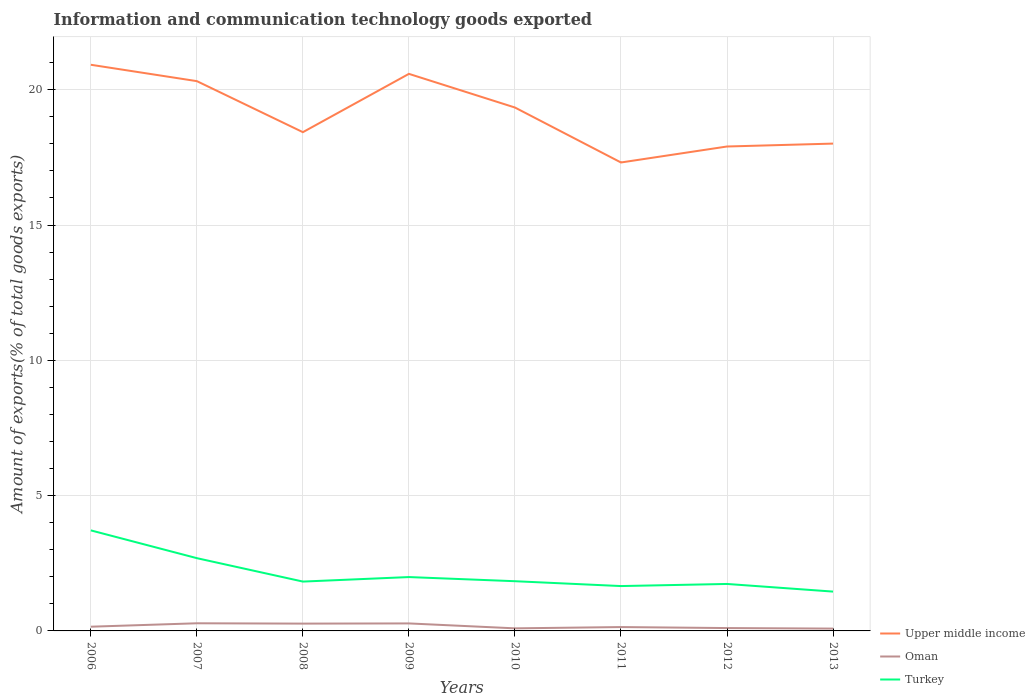Is the number of lines equal to the number of legend labels?
Offer a very short reply. Yes. Across all years, what is the maximum amount of goods exported in Oman?
Provide a succinct answer. 0.09. What is the total amount of goods exported in Upper middle income in the graph?
Ensure brevity in your answer.  1.58. What is the difference between the highest and the second highest amount of goods exported in Turkey?
Offer a very short reply. 2.26. Are the values on the major ticks of Y-axis written in scientific E-notation?
Your response must be concise. No. How are the legend labels stacked?
Offer a terse response. Vertical. What is the title of the graph?
Your answer should be very brief. Information and communication technology goods exported. What is the label or title of the Y-axis?
Make the answer very short. Amount of exports(% of total goods exports). What is the Amount of exports(% of total goods exports) of Upper middle income in 2006?
Your answer should be compact. 20.92. What is the Amount of exports(% of total goods exports) in Oman in 2006?
Ensure brevity in your answer.  0.16. What is the Amount of exports(% of total goods exports) in Turkey in 2006?
Make the answer very short. 3.72. What is the Amount of exports(% of total goods exports) in Upper middle income in 2007?
Ensure brevity in your answer.  20.32. What is the Amount of exports(% of total goods exports) of Oman in 2007?
Offer a very short reply. 0.28. What is the Amount of exports(% of total goods exports) of Turkey in 2007?
Ensure brevity in your answer.  2.69. What is the Amount of exports(% of total goods exports) in Upper middle income in 2008?
Ensure brevity in your answer.  18.43. What is the Amount of exports(% of total goods exports) of Oman in 2008?
Provide a succinct answer. 0.27. What is the Amount of exports(% of total goods exports) of Turkey in 2008?
Keep it short and to the point. 1.82. What is the Amount of exports(% of total goods exports) in Upper middle income in 2009?
Offer a terse response. 20.59. What is the Amount of exports(% of total goods exports) in Oman in 2009?
Provide a short and direct response. 0.28. What is the Amount of exports(% of total goods exports) of Turkey in 2009?
Make the answer very short. 1.99. What is the Amount of exports(% of total goods exports) of Upper middle income in 2010?
Your answer should be very brief. 19.34. What is the Amount of exports(% of total goods exports) in Oman in 2010?
Keep it short and to the point. 0.1. What is the Amount of exports(% of total goods exports) of Turkey in 2010?
Offer a terse response. 1.84. What is the Amount of exports(% of total goods exports) in Upper middle income in 2011?
Provide a succinct answer. 17.31. What is the Amount of exports(% of total goods exports) of Oman in 2011?
Offer a terse response. 0.14. What is the Amount of exports(% of total goods exports) in Turkey in 2011?
Your answer should be very brief. 1.66. What is the Amount of exports(% of total goods exports) of Upper middle income in 2012?
Make the answer very short. 17.9. What is the Amount of exports(% of total goods exports) of Oman in 2012?
Provide a short and direct response. 0.11. What is the Amount of exports(% of total goods exports) in Turkey in 2012?
Offer a terse response. 1.74. What is the Amount of exports(% of total goods exports) in Upper middle income in 2013?
Offer a terse response. 18.01. What is the Amount of exports(% of total goods exports) in Oman in 2013?
Offer a terse response. 0.09. What is the Amount of exports(% of total goods exports) of Turkey in 2013?
Offer a very short reply. 1.45. Across all years, what is the maximum Amount of exports(% of total goods exports) in Upper middle income?
Provide a short and direct response. 20.92. Across all years, what is the maximum Amount of exports(% of total goods exports) in Oman?
Offer a terse response. 0.28. Across all years, what is the maximum Amount of exports(% of total goods exports) in Turkey?
Provide a short and direct response. 3.72. Across all years, what is the minimum Amount of exports(% of total goods exports) of Upper middle income?
Your response must be concise. 17.31. Across all years, what is the minimum Amount of exports(% of total goods exports) in Oman?
Offer a very short reply. 0.09. Across all years, what is the minimum Amount of exports(% of total goods exports) in Turkey?
Your answer should be very brief. 1.45. What is the total Amount of exports(% of total goods exports) of Upper middle income in the graph?
Your response must be concise. 152.82. What is the total Amount of exports(% of total goods exports) of Oman in the graph?
Give a very brief answer. 1.42. What is the total Amount of exports(% of total goods exports) in Turkey in the graph?
Ensure brevity in your answer.  16.9. What is the difference between the Amount of exports(% of total goods exports) in Upper middle income in 2006 and that in 2007?
Offer a terse response. 0.6. What is the difference between the Amount of exports(% of total goods exports) in Oman in 2006 and that in 2007?
Provide a short and direct response. -0.13. What is the difference between the Amount of exports(% of total goods exports) of Turkey in 2006 and that in 2007?
Give a very brief answer. 1.03. What is the difference between the Amount of exports(% of total goods exports) in Upper middle income in 2006 and that in 2008?
Keep it short and to the point. 2.49. What is the difference between the Amount of exports(% of total goods exports) in Oman in 2006 and that in 2008?
Keep it short and to the point. -0.11. What is the difference between the Amount of exports(% of total goods exports) of Turkey in 2006 and that in 2008?
Provide a succinct answer. 1.89. What is the difference between the Amount of exports(% of total goods exports) of Upper middle income in 2006 and that in 2009?
Make the answer very short. 0.34. What is the difference between the Amount of exports(% of total goods exports) in Oman in 2006 and that in 2009?
Ensure brevity in your answer.  -0.12. What is the difference between the Amount of exports(% of total goods exports) of Turkey in 2006 and that in 2009?
Provide a succinct answer. 1.73. What is the difference between the Amount of exports(% of total goods exports) in Upper middle income in 2006 and that in 2010?
Offer a terse response. 1.58. What is the difference between the Amount of exports(% of total goods exports) of Oman in 2006 and that in 2010?
Your answer should be very brief. 0.06. What is the difference between the Amount of exports(% of total goods exports) of Turkey in 2006 and that in 2010?
Make the answer very short. 1.88. What is the difference between the Amount of exports(% of total goods exports) in Upper middle income in 2006 and that in 2011?
Offer a very short reply. 3.61. What is the difference between the Amount of exports(% of total goods exports) in Oman in 2006 and that in 2011?
Make the answer very short. 0.01. What is the difference between the Amount of exports(% of total goods exports) of Turkey in 2006 and that in 2011?
Your response must be concise. 2.06. What is the difference between the Amount of exports(% of total goods exports) of Upper middle income in 2006 and that in 2012?
Your response must be concise. 3.02. What is the difference between the Amount of exports(% of total goods exports) of Turkey in 2006 and that in 2012?
Give a very brief answer. 1.98. What is the difference between the Amount of exports(% of total goods exports) in Upper middle income in 2006 and that in 2013?
Your answer should be compact. 2.91. What is the difference between the Amount of exports(% of total goods exports) of Oman in 2006 and that in 2013?
Your answer should be very brief. 0.07. What is the difference between the Amount of exports(% of total goods exports) in Turkey in 2006 and that in 2013?
Make the answer very short. 2.26. What is the difference between the Amount of exports(% of total goods exports) of Upper middle income in 2007 and that in 2008?
Offer a very short reply. 1.89. What is the difference between the Amount of exports(% of total goods exports) of Oman in 2007 and that in 2008?
Provide a succinct answer. 0.01. What is the difference between the Amount of exports(% of total goods exports) in Turkey in 2007 and that in 2008?
Ensure brevity in your answer.  0.87. What is the difference between the Amount of exports(% of total goods exports) in Upper middle income in 2007 and that in 2009?
Give a very brief answer. -0.27. What is the difference between the Amount of exports(% of total goods exports) in Oman in 2007 and that in 2009?
Provide a short and direct response. 0. What is the difference between the Amount of exports(% of total goods exports) in Turkey in 2007 and that in 2009?
Provide a succinct answer. 0.7. What is the difference between the Amount of exports(% of total goods exports) in Upper middle income in 2007 and that in 2010?
Give a very brief answer. 0.97. What is the difference between the Amount of exports(% of total goods exports) of Oman in 2007 and that in 2010?
Your response must be concise. 0.19. What is the difference between the Amount of exports(% of total goods exports) in Turkey in 2007 and that in 2010?
Provide a succinct answer. 0.85. What is the difference between the Amount of exports(% of total goods exports) in Upper middle income in 2007 and that in 2011?
Offer a very short reply. 3.01. What is the difference between the Amount of exports(% of total goods exports) of Oman in 2007 and that in 2011?
Offer a terse response. 0.14. What is the difference between the Amount of exports(% of total goods exports) in Turkey in 2007 and that in 2011?
Provide a short and direct response. 1.03. What is the difference between the Amount of exports(% of total goods exports) in Upper middle income in 2007 and that in 2012?
Ensure brevity in your answer.  2.42. What is the difference between the Amount of exports(% of total goods exports) in Oman in 2007 and that in 2012?
Give a very brief answer. 0.18. What is the difference between the Amount of exports(% of total goods exports) of Turkey in 2007 and that in 2012?
Ensure brevity in your answer.  0.95. What is the difference between the Amount of exports(% of total goods exports) in Upper middle income in 2007 and that in 2013?
Your answer should be compact. 2.31. What is the difference between the Amount of exports(% of total goods exports) of Oman in 2007 and that in 2013?
Keep it short and to the point. 0.2. What is the difference between the Amount of exports(% of total goods exports) in Turkey in 2007 and that in 2013?
Offer a terse response. 1.24. What is the difference between the Amount of exports(% of total goods exports) in Upper middle income in 2008 and that in 2009?
Keep it short and to the point. -2.15. What is the difference between the Amount of exports(% of total goods exports) of Oman in 2008 and that in 2009?
Your answer should be very brief. -0.01. What is the difference between the Amount of exports(% of total goods exports) of Turkey in 2008 and that in 2009?
Keep it short and to the point. -0.17. What is the difference between the Amount of exports(% of total goods exports) of Upper middle income in 2008 and that in 2010?
Give a very brief answer. -0.91. What is the difference between the Amount of exports(% of total goods exports) in Oman in 2008 and that in 2010?
Your answer should be compact. 0.17. What is the difference between the Amount of exports(% of total goods exports) of Turkey in 2008 and that in 2010?
Your answer should be compact. -0.01. What is the difference between the Amount of exports(% of total goods exports) in Upper middle income in 2008 and that in 2011?
Give a very brief answer. 1.12. What is the difference between the Amount of exports(% of total goods exports) of Oman in 2008 and that in 2011?
Ensure brevity in your answer.  0.13. What is the difference between the Amount of exports(% of total goods exports) of Turkey in 2008 and that in 2011?
Your response must be concise. 0.17. What is the difference between the Amount of exports(% of total goods exports) of Upper middle income in 2008 and that in 2012?
Ensure brevity in your answer.  0.53. What is the difference between the Amount of exports(% of total goods exports) in Oman in 2008 and that in 2012?
Your answer should be compact. 0.16. What is the difference between the Amount of exports(% of total goods exports) in Turkey in 2008 and that in 2012?
Provide a succinct answer. 0.09. What is the difference between the Amount of exports(% of total goods exports) in Upper middle income in 2008 and that in 2013?
Keep it short and to the point. 0.42. What is the difference between the Amount of exports(% of total goods exports) in Oman in 2008 and that in 2013?
Offer a very short reply. 0.18. What is the difference between the Amount of exports(% of total goods exports) of Turkey in 2008 and that in 2013?
Provide a succinct answer. 0.37. What is the difference between the Amount of exports(% of total goods exports) of Upper middle income in 2009 and that in 2010?
Ensure brevity in your answer.  1.24. What is the difference between the Amount of exports(% of total goods exports) in Oman in 2009 and that in 2010?
Your answer should be compact. 0.18. What is the difference between the Amount of exports(% of total goods exports) in Turkey in 2009 and that in 2010?
Offer a terse response. 0.15. What is the difference between the Amount of exports(% of total goods exports) of Upper middle income in 2009 and that in 2011?
Make the answer very short. 3.27. What is the difference between the Amount of exports(% of total goods exports) in Oman in 2009 and that in 2011?
Provide a succinct answer. 0.13. What is the difference between the Amount of exports(% of total goods exports) of Turkey in 2009 and that in 2011?
Provide a short and direct response. 0.33. What is the difference between the Amount of exports(% of total goods exports) in Upper middle income in 2009 and that in 2012?
Ensure brevity in your answer.  2.68. What is the difference between the Amount of exports(% of total goods exports) in Oman in 2009 and that in 2012?
Provide a succinct answer. 0.17. What is the difference between the Amount of exports(% of total goods exports) in Turkey in 2009 and that in 2012?
Offer a very short reply. 0.25. What is the difference between the Amount of exports(% of total goods exports) in Upper middle income in 2009 and that in 2013?
Make the answer very short. 2.58. What is the difference between the Amount of exports(% of total goods exports) of Oman in 2009 and that in 2013?
Keep it short and to the point. 0.19. What is the difference between the Amount of exports(% of total goods exports) in Turkey in 2009 and that in 2013?
Provide a short and direct response. 0.54. What is the difference between the Amount of exports(% of total goods exports) of Upper middle income in 2010 and that in 2011?
Your answer should be very brief. 2.03. What is the difference between the Amount of exports(% of total goods exports) in Oman in 2010 and that in 2011?
Keep it short and to the point. -0.05. What is the difference between the Amount of exports(% of total goods exports) in Turkey in 2010 and that in 2011?
Your answer should be very brief. 0.18. What is the difference between the Amount of exports(% of total goods exports) in Upper middle income in 2010 and that in 2012?
Your response must be concise. 1.44. What is the difference between the Amount of exports(% of total goods exports) in Oman in 2010 and that in 2012?
Your response must be concise. -0.01. What is the difference between the Amount of exports(% of total goods exports) in Turkey in 2010 and that in 2012?
Ensure brevity in your answer.  0.1. What is the difference between the Amount of exports(% of total goods exports) of Upper middle income in 2010 and that in 2013?
Make the answer very short. 1.33. What is the difference between the Amount of exports(% of total goods exports) of Oman in 2010 and that in 2013?
Your response must be concise. 0.01. What is the difference between the Amount of exports(% of total goods exports) in Turkey in 2010 and that in 2013?
Keep it short and to the point. 0.38. What is the difference between the Amount of exports(% of total goods exports) in Upper middle income in 2011 and that in 2012?
Your answer should be very brief. -0.59. What is the difference between the Amount of exports(% of total goods exports) in Oman in 2011 and that in 2012?
Your response must be concise. 0.04. What is the difference between the Amount of exports(% of total goods exports) in Turkey in 2011 and that in 2012?
Your answer should be compact. -0.08. What is the difference between the Amount of exports(% of total goods exports) in Upper middle income in 2011 and that in 2013?
Make the answer very short. -0.7. What is the difference between the Amount of exports(% of total goods exports) of Oman in 2011 and that in 2013?
Offer a very short reply. 0.06. What is the difference between the Amount of exports(% of total goods exports) in Turkey in 2011 and that in 2013?
Provide a succinct answer. 0.2. What is the difference between the Amount of exports(% of total goods exports) of Upper middle income in 2012 and that in 2013?
Your response must be concise. -0.11. What is the difference between the Amount of exports(% of total goods exports) in Oman in 2012 and that in 2013?
Offer a terse response. 0.02. What is the difference between the Amount of exports(% of total goods exports) in Turkey in 2012 and that in 2013?
Your answer should be very brief. 0.28. What is the difference between the Amount of exports(% of total goods exports) of Upper middle income in 2006 and the Amount of exports(% of total goods exports) of Oman in 2007?
Provide a succinct answer. 20.64. What is the difference between the Amount of exports(% of total goods exports) in Upper middle income in 2006 and the Amount of exports(% of total goods exports) in Turkey in 2007?
Offer a terse response. 18.23. What is the difference between the Amount of exports(% of total goods exports) of Oman in 2006 and the Amount of exports(% of total goods exports) of Turkey in 2007?
Offer a very short reply. -2.53. What is the difference between the Amount of exports(% of total goods exports) in Upper middle income in 2006 and the Amount of exports(% of total goods exports) in Oman in 2008?
Ensure brevity in your answer.  20.65. What is the difference between the Amount of exports(% of total goods exports) of Upper middle income in 2006 and the Amount of exports(% of total goods exports) of Turkey in 2008?
Keep it short and to the point. 19.1. What is the difference between the Amount of exports(% of total goods exports) in Oman in 2006 and the Amount of exports(% of total goods exports) in Turkey in 2008?
Offer a terse response. -1.67. What is the difference between the Amount of exports(% of total goods exports) in Upper middle income in 2006 and the Amount of exports(% of total goods exports) in Oman in 2009?
Provide a short and direct response. 20.64. What is the difference between the Amount of exports(% of total goods exports) in Upper middle income in 2006 and the Amount of exports(% of total goods exports) in Turkey in 2009?
Make the answer very short. 18.93. What is the difference between the Amount of exports(% of total goods exports) of Oman in 2006 and the Amount of exports(% of total goods exports) of Turkey in 2009?
Ensure brevity in your answer.  -1.83. What is the difference between the Amount of exports(% of total goods exports) of Upper middle income in 2006 and the Amount of exports(% of total goods exports) of Oman in 2010?
Your answer should be very brief. 20.83. What is the difference between the Amount of exports(% of total goods exports) of Upper middle income in 2006 and the Amount of exports(% of total goods exports) of Turkey in 2010?
Keep it short and to the point. 19.08. What is the difference between the Amount of exports(% of total goods exports) in Oman in 2006 and the Amount of exports(% of total goods exports) in Turkey in 2010?
Your answer should be very brief. -1.68. What is the difference between the Amount of exports(% of total goods exports) of Upper middle income in 2006 and the Amount of exports(% of total goods exports) of Oman in 2011?
Give a very brief answer. 20.78. What is the difference between the Amount of exports(% of total goods exports) of Upper middle income in 2006 and the Amount of exports(% of total goods exports) of Turkey in 2011?
Provide a short and direct response. 19.26. What is the difference between the Amount of exports(% of total goods exports) in Oman in 2006 and the Amount of exports(% of total goods exports) in Turkey in 2011?
Offer a terse response. -1.5. What is the difference between the Amount of exports(% of total goods exports) of Upper middle income in 2006 and the Amount of exports(% of total goods exports) of Oman in 2012?
Provide a succinct answer. 20.82. What is the difference between the Amount of exports(% of total goods exports) of Upper middle income in 2006 and the Amount of exports(% of total goods exports) of Turkey in 2012?
Offer a very short reply. 19.19. What is the difference between the Amount of exports(% of total goods exports) of Oman in 2006 and the Amount of exports(% of total goods exports) of Turkey in 2012?
Provide a short and direct response. -1.58. What is the difference between the Amount of exports(% of total goods exports) in Upper middle income in 2006 and the Amount of exports(% of total goods exports) in Oman in 2013?
Keep it short and to the point. 20.84. What is the difference between the Amount of exports(% of total goods exports) of Upper middle income in 2006 and the Amount of exports(% of total goods exports) of Turkey in 2013?
Provide a succinct answer. 19.47. What is the difference between the Amount of exports(% of total goods exports) in Oman in 2006 and the Amount of exports(% of total goods exports) in Turkey in 2013?
Give a very brief answer. -1.3. What is the difference between the Amount of exports(% of total goods exports) of Upper middle income in 2007 and the Amount of exports(% of total goods exports) of Oman in 2008?
Ensure brevity in your answer.  20.05. What is the difference between the Amount of exports(% of total goods exports) in Upper middle income in 2007 and the Amount of exports(% of total goods exports) in Turkey in 2008?
Give a very brief answer. 18.49. What is the difference between the Amount of exports(% of total goods exports) in Oman in 2007 and the Amount of exports(% of total goods exports) in Turkey in 2008?
Your answer should be compact. -1.54. What is the difference between the Amount of exports(% of total goods exports) of Upper middle income in 2007 and the Amount of exports(% of total goods exports) of Oman in 2009?
Your response must be concise. 20.04. What is the difference between the Amount of exports(% of total goods exports) of Upper middle income in 2007 and the Amount of exports(% of total goods exports) of Turkey in 2009?
Provide a succinct answer. 18.33. What is the difference between the Amount of exports(% of total goods exports) of Oman in 2007 and the Amount of exports(% of total goods exports) of Turkey in 2009?
Ensure brevity in your answer.  -1.71. What is the difference between the Amount of exports(% of total goods exports) of Upper middle income in 2007 and the Amount of exports(% of total goods exports) of Oman in 2010?
Keep it short and to the point. 20.22. What is the difference between the Amount of exports(% of total goods exports) in Upper middle income in 2007 and the Amount of exports(% of total goods exports) in Turkey in 2010?
Keep it short and to the point. 18.48. What is the difference between the Amount of exports(% of total goods exports) of Oman in 2007 and the Amount of exports(% of total goods exports) of Turkey in 2010?
Your response must be concise. -1.55. What is the difference between the Amount of exports(% of total goods exports) of Upper middle income in 2007 and the Amount of exports(% of total goods exports) of Oman in 2011?
Your answer should be very brief. 20.17. What is the difference between the Amount of exports(% of total goods exports) in Upper middle income in 2007 and the Amount of exports(% of total goods exports) in Turkey in 2011?
Your response must be concise. 18.66. What is the difference between the Amount of exports(% of total goods exports) in Oman in 2007 and the Amount of exports(% of total goods exports) in Turkey in 2011?
Make the answer very short. -1.38. What is the difference between the Amount of exports(% of total goods exports) of Upper middle income in 2007 and the Amount of exports(% of total goods exports) of Oman in 2012?
Your answer should be very brief. 20.21. What is the difference between the Amount of exports(% of total goods exports) in Upper middle income in 2007 and the Amount of exports(% of total goods exports) in Turkey in 2012?
Provide a succinct answer. 18.58. What is the difference between the Amount of exports(% of total goods exports) of Oman in 2007 and the Amount of exports(% of total goods exports) of Turkey in 2012?
Provide a short and direct response. -1.45. What is the difference between the Amount of exports(% of total goods exports) of Upper middle income in 2007 and the Amount of exports(% of total goods exports) of Oman in 2013?
Your answer should be very brief. 20.23. What is the difference between the Amount of exports(% of total goods exports) in Upper middle income in 2007 and the Amount of exports(% of total goods exports) in Turkey in 2013?
Provide a short and direct response. 18.86. What is the difference between the Amount of exports(% of total goods exports) in Oman in 2007 and the Amount of exports(% of total goods exports) in Turkey in 2013?
Give a very brief answer. -1.17. What is the difference between the Amount of exports(% of total goods exports) of Upper middle income in 2008 and the Amount of exports(% of total goods exports) of Oman in 2009?
Your answer should be compact. 18.15. What is the difference between the Amount of exports(% of total goods exports) in Upper middle income in 2008 and the Amount of exports(% of total goods exports) in Turkey in 2009?
Your answer should be compact. 16.44. What is the difference between the Amount of exports(% of total goods exports) of Oman in 2008 and the Amount of exports(% of total goods exports) of Turkey in 2009?
Offer a very short reply. -1.72. What is the difference between the Amount of exports(% of total goods exports) of Upper middle income in 2008 and the Amount of exports(% of total goods exports) of Oman in 2010?
Your response must be concise. 18.34. What is the difference between the Amount of exports(% of total goods exports) of Upper middle income in 2008 and the Amount of exports(% of total goods exports) of Turkey in 2010?
Offer a very short reply. 16.59. What is the difference between the Amount of exports(% of total goods exports) in Oman in 2008 and the Amount of exports(% of total goods exports) in Turkey in 2010?
Your answer should be very brief. -1.57. What is the difference between the Amount of exports(% of total goods exports) of Upper middle income in 2008 and the Amount of exports(% of total goods exports) of Oman in 2011?
Your answer should be very brief. 18.29. What is the difference between the Amount of exports(% of total goods exports) in Upper middle income in 2008 and the Amount of exports(% of total goods exports) in Turkey in 2011?
Offer a terse response. 16.77. What is the difference between the Amount of exports(% of total goods exports) of Oman in 2008 and the Amount of exports(% of total goods exports) of Turkey in 2011?
Your answer should be compact. -1.39. What is the difference between the Amount of exports(% of total goods exports) in Upper middle income in 2008 and the Amount of exports(% of total goods exports) in Oman in 2012?
Offer a very short reply. 18.33. What is the difference between the Amount of exports(% of total goods exports) of Upper middle income in 2008 and the Amount of exports(% of total goods exports) of Turkey in 2012?
Ensure brevity in your answer.  16.7. What is the difference between the Amount of exports(% of total goods exports) of Oman in 2008 and the Amount of exports(% of total goods exports) of Turkey in 2012?
Keep it short and to the point. -1.47. What is the difference between the Amount of exports(% of total goods exports) of Upper middle income in 2008 and the Amount of exports(% of total goods exports) of Oman in 2013?
Your response must be concise. 18.35. What is the difference between the Amount of exports(% of total goods exports) of Upper middle income in 2008 and the Amount of exports(% of total goods exports) of Turkey in 2013?
Provide a succinct answer. 16.98. What is the difference between the Amount of exports(% of total goods exports) in Oman in 2008 and the Amount of exports(% of total goods exports) in Turkey in 2013?
Keep it short and to the point. -1.18. What is the difference between the Amount of exports(% of total goods exports) of Upper middle income in 2009 and the Amount of exports(% of total goods exports) of Oman in 2010?
Make the answer very short. 20.49. What is the difference between the Amount of exports(% of total goods exports) in Upper middle income in 2009 and the Amount of exports(% of total goods exports) in Turkey in 2010?
Provide a short and direct response. 18.75. What is the difference between the Amount of exports(% of total goods exports) of Oman in 2009 and the Amount of exports(% of total goods exports) of Turkey in 2010?
Ensure brevity in your answer.  -1.56. What is the difference between the Amount of exports(% of total goods exports) of Upper middle income in 2009 and the Amount of exports(% of total goods exports) of Oman in 2011?
Ensure brevity in your answer.  20.44. What is the difference between the Amount of exports(% of total goods exports) in Upper middle income in 2009 and the Amount of exports(% of total goods exports) in Turkey in 2011?
Offer a very short reply. 18.93. What is the difference between the Amount of exports(% of total goods exports) in Oman in 2009 and the Amount of exports(% of total goods exports) in Turkey in 2011?
Offer a very short reply. -1.38. What is the difference between the Amount of exports(% of total goods exports) in Upper middle income in 2009 and the Amount of exports(% of total goods exports) in Oman in 2012?
Ensure brevity in your answer.  20.48. What is the difference between the Amount of exports(% of total goods exports) in Upper middle income in 2009 and the Amount of exports(% of total goods exports) in Turkey in 2012?
Your answer should be compact. 18.85. What is the difference between the Amount of exports(% of total goods exports) of Oman in 2009 and the Amount of exports(% of total goods exports) of Turkey in 2012?
Your answer should be compact. -1.46. What is the difference between the Amount of exports(% of total goods exports) in Upper middle income in 2009 and the Amount of exports(% of total goods exports) in Oman in 2013?
Offer a very short reply. 20.5. What is the difference between the Amount of exports(% of total goods exports) of Upper middle income in 2009 and the Amount of exports(% of total goods exports) of Turkey in 2013?
Provide a short and direct response. 19.13. What is the difference between the Amount of exports(% of total goods exports) of Oman in 2009 and the Amount of exports(% of total goods exports) of Turkey in 2013?
Make the answer very short. -1.18. What is the difference between the Amount of exports(% of total goods exports) of Upper middle income in 2010 and the Amount of exports(% of total goods exports) of Oman in 2011?
Keep it short and to the point. 19.2. What is the difference between the Amount of exports(% of total goods exports) of Upper middle income in 2010 and the Amount of exports(% of total goods exports) of Turkey in 2011?
Provide a succinct answer. 17.68. What is the difference between the Amount of exports(% of total goods exports) in Oman in 2010 and the Amount of exports(% of total goods exports) in Turkey in 2011?
Your answer should be very brief. -1.56. What is the difference between the Amount of exports(% of total goods exports) of Upper middle income in 2010 and the Amount of exports(% of total goods exports) of Oman in 2012?
Offer a terse response. 19.24. What is the difference between the Amount of exports(% of total goods exports) in Upper middle income in 2010 and the Amount of exports(% of total goods exports) in Turkey in 2012?
Keep it short and to the point. 17.61. What is the difference between the Amount of exports(% of total goods exports) in Oman in 2010 and the Amount of exports(% of total goods exports) in Turkey in 2012?
Give a very brief answer. -1.64. What is the difference between the Amount of exports(% of total goods exports) in Upper middle income in 2010 and the Amount of exports(% of total goods exports) in Oman in 2013?
Your answer should be compact. 19.26. What is the difference between the Amount of exports(% of total goods exports) of Upper middle income in 2010 and the Amount of exports(% of total goods exports) of Turkey in 2013?
Keep it short and to the point. 17.89. What is the difference between the Amount of exports(% of total goods exports) of Oman in 2010 and the Amount of exports(% of total goods exports) of Turkey in 2013?
Your answer should be compact. -1.36. What is the difference between the Amount of exports(% of total goods exports) in Upper middle income in 2011 and the Amount of exports(% of total goods exports) in Oman in 2012?
Provide a short and direct response. 17.21. What is the difference between the Amount of exports(% of total goods exports) of Upper middle income in 2011 and the Amount of exports(% of total goods exports) of Turkey in 2012?
Your response must be concise. 15.58. What is the difference between the Amount of exports(% of total goods exports) in Oman in 2011 and the Amount of exports(% of total goods exports) in Turkey in 2012?
Offer a terse response. -1.59. What is the difference between the Amount of exports(% of total goods exports) in Upper middle income in 2011 and the Amount of exports(% of total goods exports) in Oman in 2013?
Keep it short and to the point. 17.23. What is the difference between the Amount of exports(% of total goods exports) in Upper middle income in 2011 and the Amount of exports(% of total goods exports) in Turkey in 2013?
Keep it short and to the point. 15.86. What is the difference between the Amount of exports(% of total goods exports) in Oman in 2011 and the Amount of exports(% of total goods exports) in Turkey in 2013?
Provide a short and direct response. -1.31. What is the difference between the Amount of exports(% of total goods exports) of Upper middle income in 2012 and the Amount of exports(% of total goods exports) of Oman in 2013?
Make the answer very short. 17.82. What is the difference between the Amount of exports(% of total goods exports) in Upper middle income in 2012 and the Amount of exports(% of total goods exports) in Turkey in 2013?
Offer a very short reply. 16.45. What is the difference between the Amount of exports(% of total goods exports) of Oman in 2012 and the Amount of exports(% of total goods exports) of Turkey in 2013?
Provide a short and direct response. -1.35. What is the average Amount of exports(% of total goods exports) of Upper middle income per year?
Provide a short and direct response. 19.1. What is the average Amount of exports(% of total goods exports) in Oman per year?
Your answer should be compact. 0.18. What is the average Amount of exports(% of total goods exports) of Turkey per year?
Ensure brevity in your answer.  2.11. In the year 2006, what is the difference between the Amount of exports(% of total goods exports) in Upper middle income and Amount of exports(% of total goods exports) in Oman?
Make the answer very short. 20.77. In the year 2006, what is the difference between the Amount of exports(% of total goods exports) in Upper middle income and Amount of exports(% of total goods exports) in Turkey?
Keep it short and to the point. 17.21. In the year 2006, what is the difference between the Amount of exports(% of total goods exports) in Oman and Amount of exports(% of total goods exports) in Turkey?
Give a very brief answer. -3.56. In the year 2007, what is the difference between the Amount of exports(% of total goods exports) in Upper middle income and Amount of exports(% of total goods exports) in Oman?
Your answer should be compact. 20.03. In the year 2007, what is the difference between the Amount of exports(% of total goods exports) of Upper middle income and Amount of exports(% of total goods exports) of Turkey?
Provide a succinct answer. 17.63. In the year 2007, what is the difference between the Amount of exports(% of total goods exports) in Oman and Amount of exports(% of total goods exports) in Turkey?
Provide a succinct answer. -2.41. In the year 2008, what is the difference between the Amount of exports(% of total goods exports) in Upper middle income and Amount of exports(% of total goods exports) in Oman?
Give a very brief answer. 18.16. In the year 2008, what is the difference between the Amount of exports(% of total goods exports) in Upper middle income and Amount of exports(% of total goods exports) in Turkey?
Offer a terse response. 16.61. In the year 2008, what is the difference between the Amount of exports(% of total goods exports) in Oman and Amount of exports(% of total goods exports) in Turkey?
Your answer should be compact. -1.55. In the year 2009, what is the difference between the Amount of exports(% of total goods exports) in Upper middle income and Amount of exports(% of total goods exports) in Oman?
Your response must be concise. 20.31. In the year 2009, what is the difference between the Amount of exports(% of total goods exports) of Upper middle income and Amount of exports(% of total goods exports) of Turkey?
Offer a very short reply. 18.6. In the year 2009, what is the difference between the Amount of exports(% of total goods exports) in Oman and Amount of exports(% of total goods exports) in Turkey?
Provide a succinct answer. -1.71. In the year 2010, what is the difference between the Amount of exports(% of total goods exports) of Upper middle income and Amount of exports(% of total goods exports) of Oman?
Your answer should be very brief. 19.25. In the year 2010, what is the difference between the Amount of exports(% of total goods exports) of Upper middle income and Amount of exports(% of total goods exports) of Turkey?
Offer a very short reply. 17.5. In the year 2010, what is the difference between the Amount of exports(% of total goods exports) in Oman and Amount of exports(% of total goods exports) in Turkey?
Offer a terse response. -1.74. In the year 2011, what is the difference between the Amount of exports(% of total goods exports) of Upper middle income and Amount of exports(% of total goods exports) of Oman?
Ensure brevity in your answer.  17.17. In the year 2011, what is the difference between the Amount of exports(% of total goods exports) of Upper middle income and Amount of exports(% of total goods exports) of Turkey?
Provide a succinct answer. 15.65. In the year 2011, what is the difference between the Amount of exports(% of total goods exports) in Oman and Amount of exports(% of total goods exports) in Turkey?
Offer a very short reply. -1.51. In the year 2012, what is the difference between the Amount of exports(% of total goods exports) in Upper middle income and Amount of exports(% of total goods exports) in Oman?
Your answer should be compact. 17.8. In the year 2012, what is the difference between the Amount of exports(% of total goods exports) of Upper middle income and Amount of exports(% of total goods exports) of Turkey?
Your response must be concise. 16.17. In the year 2012, what is the difference between the Amount of exports(% of total goods exports) of Oman and Amount of exports(% of total goods exports) of Turkey?
Offer a very short reply. -1.63. In the year 2013, what is the difference between the Amount of exports(% of total goods exports) of Upper middle income and Amount of exports(% of total goods exports) of Oman?
Provide a short and direct response. 17.92. In the year 2013, what is the difference between the Amount of exports(% of total goods exports) in Upper middle income and Amount of exports(% of total goods exports) in Turkey?
Your response must be concise. 16.56. In the year 2013, what is the difference between the Amount of exports(% of total goods exports) in Oman and Amount of exports(% of total goods exports) in Turkey?
Give a very brief answer. -1.37. What is the ratio of the Amount of exports(% of total goods exports) of Upper middle income in 2006 to that in 2007?
Offer a very short reply. 1.03. What is the ratio of the Amount of exports(% of total goods exports) in Oman in 2006 to that in 2007?
Keep it short and to the point. 0.55. What is the ratio of the Amount of exports(% of total goods exports) in Turkey in 2006 to that in 2007?
Provide a succinct answer. 1.38. What is the ratio of the Amount of exports(% of total goods exports) in Upper middle income in 2006 to that in 2008?
Your response must be concise. 1.14. What is the ratio of the Amount of exports(% of total goods exports) of Oman in 2006 to that in 2008?
Offer a terse response. 0.58. What is the ratio of the Amount of exports(% of total goods exports) in Turkey in 2006 to that in 2008?
Provide a succinct answer. 2.04. What is the ratio of the Amount of exports(% of total goods exports) in Upper middle income in 2006 to that in 2009?
Your answer should be very brief. 1.02. What is the ratio of the Amount of exports(% of total goods exports) of Oman in 2006 to that in 2009?
Keep it short and to the point. 0.56. What is the ratio of the Amount of exports(% of total goods exports) of Turkey in 2006 to that in 2009?
Keep it short and to the point. 1.87. What is the ratio of the Amount of exports(% of total goods exports) in Upper middle income in 2006 to that in 2010?
Offer a terse response. 1.08. What is the ratio of the Amount of exports(% of total goods exports) in Oman in 2006 to that in 2010?
Provide a succinct answer. 1.63. What is the ratio of the Amount of exports(% of total goods exports) in Turkey in 2006 to that in 2010?
Provide a short and direct response. 2.02. What is the ratio of the Amount of exports(% of total goods exports) of Upper middle income in 2006 to that in 2011?
Provide a short and direct response. 1.21. What is the ratio of the Amount of exports(% of total goods exports) of Oman in 2006 to that in 2011?
Your answer should be compact. 1.09. What is the ratio of the Amount of exports(% of total goods exports) of Turkey in 2006 to that in 2011?
Make the answer very short. 2.24. What is the ratio of the Amount of exports(% of total goods exports) in Upper middle income in 2006 to that in 2012?
Offer a very short reply. 1.17. What is the ratio of the Amount of exports(% of total goods exports) of Oman in 2006 to that in 2012?
Your answer should be compact. 1.47. What is the ratio of the Amount of exports(% of total goods exports) in Turkey in 2006 to that in 2012?
Give a very brief answer. 2.14. What is the ratio of the Amount of exports(% of total goods exports) in Upper middle income in 2006 to that in 2013?
Give a very brief answer. 1.16. What is the ratio of the Amount of exports(% of total goods exports) in Oman in 2006 to that in 2013?
Make the answer very short. 1.82. What is the ratio of the Amount of exports(% of total goods exports) in Turkey in 2006 to that in 2013?
Provide a short and direct response. 2.56. What is the ratio of the Amount of exports(% of total goods exports) of Upper middle income in 2007 to that in 2008?
Your answer should be very brief. 1.1. What is the ratio of the Amount of exports(% of total goods exports) of Oman in 2007 to that in 2008?
Give a very brief answer. 1.04. What is the ratio of the Amount of exports(% of total goods exports) in Turkey in 2007 to that in 2008?
Your answer should be very brief. 1.47. What is the ratio of the Amount of exports(% of total goods exports) of Upper middle income in 2007 to that in 2009?
Your response must be concise. 0.99. What is the ratio of the Amount of exports(% of total goods exports) of Oman in 2007 to that in 2009?
Your answer should be compact. 1.02. What is the ratio of the Amount of exports(% of total goods exports) of Turkey in 2007 to that in 2009?
Ensure brevity in your answer.  1.35. What is the ratio of the Amount of exports(% of total goods exports) of Upper middle income in 2007 to that in 2010?
Provide a succinct answer. 1.05. What is the ratio of the Amount of exports(% of total goods exports) of Oman in 2007 to that in 2010?
Keep it short and to the point. 2.96. What is the ratio of the Amount of exports(% of total goods exports) in Turkey in 2007 to that in 2010?
Provide a succinct answer. 1.46. What is the ratio of the Amount of exports(% of total goods exports) of Upper middle income in 2007 to that in 2011?
Your response must be concise. 1.17. What is the ratio of the Amount of exports(% of total goods exports) in Oman in 2007 to that in 2011?
Keep it short and to the point. 1.98. What is the ratio of the Amount of exports(% of total goods exports) in Turkey in 2007 to that in 2011?
Your answer should be compact. 1.62. What is the ratio of the Amount of exports(% of total goods exports) in Upper middle income in 2007 to that in 2012?
Your response must be concise. 1.13. What is the ratio of the Amount of exports(% of total goods exports) in Oman in 2007 to that in 2012?
Your response must be concise. 2.67. What is the ratio of the Amount of exports(% of total goods exports) in Turkey in 2007 to that in 2012?
Your answer should be compact. 1.55. What is the ratio of the Amount of exports(% of total goods exports) in Upper middle income in 2007 to that in 2013?
Make the answer very short. 1.13. What is the ratio of the Amount of exports(% of total goods exports) in Oman in 2007 to that in 2013?
Your answer should be compact. 3.29. What is the ratio of the Amount of exports(% of total goods exports) of Turkey in 2007 to that in 2013?
Your answer should be compact. 1.85. What is the ratio of the Amount of exports(% of total goods exports) in Upper middle income in 2008 to that in 2009?
Provide a succinct answer. 0.9. What is the ratio of the Amount of exports(% of total goods exports) in Oman in 2008 to that in 2009?
Ensure brevity in your answer.  0.97. What is the ratio of the Amount of exports(% of total goods exports) in Turkey in 2008 to that in 2009?
Provide a succinct answer. 0.92. What is the ratio of the Amount of exports(% of total goods exports) in Upper middle income in 2008 to that in 2010?
Give a very brief answer. 0.95. What is the ratio of the Amount of exports(% of total goods exports) of Oman in 2008 to that in 2010?
Offer a terse response. 2.83. What is the ratio of the Amount of exports(% of total goods exports) in Upper middle income in 2008 to that in 2011?
Ensure brevity in your answer.  1.06. What is the ratio of the Amount of exports(% of total goods exports) in Oman in 2008 to that in 2011?
Ensure brevity in your answer.  1.89. What is the ratio of the Amount of exports(% of total goods exports) in Turkey in 2008 to that in 2011?
Keep it short and to the point. 1.1. What is the ratio of the Amount of exports(% of total goods exports) in Upper middle income in 2008 to that in 2012?
Provide a succinct answer. 1.03. What is the ratio of the Amount of exports(% of total goods exports) of Oman in 2008 to that in 2012?
Give a very brief answer. 2.55. What is the ratio of the Amount of exports(% of total goods exports) in Turkey in 2008 to that in 2012?
Your answer should be very brief. 1.05. What is the ratio of the Amount of exports(% of total goods exports) in Upper middle income in 2008 to that in 2013?
Your answer should be compact. 1.02. What is the ratio of the Amount of exports(% of total goods exports) in Oman in 2008 to that in 2013?
Keep it short and to the point. 3.15. What is the ratio of the Amount of exports(% of total goods exports) in Turkey in 2008 to that in 2013?
Offer a very short reply. 1.25. What is the ratio of the Amount of exports(% of total goods exports) in Upper middle income in 2009 to that in 2010?
Ensure brevity in your answer.  1.06. What is the ratio of the Amount of exports(% of total goods exports) of Oman in 2009 to that in 2010?
Ensure brevity in your answer.  2.91. What is the ratio of the Amount of exports(% of total goods exports) of Turkey in 2009 to that in 2010?
Your answer should be very brief. 1.08. What is the ratio of the Amount of exports(% of total goods exports) of Upper middle income in 2009 to that in 2011?
Your answer should be compact. 1.19. What is the ratio of the Amount of exports(% of total goods exports) of Oman in 2009 to that in 2011?
Your answer should be very brief. 1.94. What is the ratio of the Amount of exports(% of total goods exports) in Turkey in 2009 to that in 2011?
Keep it short and to the point. 1.2. What is the ratio of the Amount of exports(% of total goods exports) of Upper middle income in 2009 to that in 2012?
Ensure brevity in your answer.  1.15. What is the ratio of the Amount of exports(% of total goods exports) in Oman in 2009 to that in 2012?
Your response must be concise. 2.62. What is the ratio of the Amount of exports(% of total goods exports) in Turkey in 2009 to that in 2012?
Give a very brief answer. 1.15. What is the ratio of the Amount of exports(% of total goods exports) in Upper middle income in 2009 to that in 2013?
Your answer should be very brief. 1.14. What is the ratio of the Amount of exports(% of total goods exports) in Oman in 2009 to that in 2013?
Provide a succinct answer. 3.23. What is the ratio of the Amount of exports(% of total goods exports) in Turkey in 2009 to that in 2013?
Ensure brevity in your answer.  1.37. What is the ratio of the Amount of exports(% of total goods exports) of Upper middle income in 2010 to that in 2011?
Your answer should be very brief. 1.12. What is the ratio of the Amount of exports(% of total goods exports) of Oman in 2010 to that in 2011?
Offer a terse response. 0.67. What is the ratio of the Amount of exports(% of total goods exports) of Turkey in 2010 to that in 2011?
Your answer should be compact. 1.11. What is the ratio of the Amount of exports(% of total goods exports) in Upper middle income in 2010 to that in 2012?
Your answer should be very brief. 1.08. What is the ratio of the Amount of exports(% of total goods exports) in Oman in 2010 to that in 2012?
Your answer should be very brief. 0.9. What is the ratio of the Amount of exports(% of total goods exports) in Turkey in 2010 to that in 2012?
Your answer should be very brief. 1.06. What is the ratio of the Amount of exports(% of total goods exports) of Upper middle income in 2010 to that in 2013?
Your response must be concise. 1.07. What is the ratio of the Amount of exports(% of total goods exports) in Oman in 2010 to that in 2013?
Make the answer very short. 1.11. What is the ratio of the Amount of exports(% of total goods exports) of Turkey in 2010 to that in 2013?
Offer a very short reply. 1.26. What is the ratio of the Amount of exports(% of total goods exports) of Upper middle income in 2011 to that in 2012?
Offer a terse response. 0.97. What is the ratio of the Amount of exports(% of total goods exports) of Oman in 2011 to that in 2012?
Offer a very short reply. 1.35. What is the ratio of the Amount of exports(% of total goods exports) of Turkey in 2011 to that in 2012?
Give a very brief answer. 0.96. What is the ratio of the Amount of exports(% of total goods exports) in Upper middle income in 2011 to that in 2013?
Keep it short and to the point. 0.96. What is the ratio of the Amount of exports(% of total goods exports) of Oman in 2011 to that in 2013?
Your response must be concise. 1.66. What is the ratio of the Amount of exports(% of total goods exports) of Turkey in 2011 to that in 2013?
Make the answer very short. 1.14. What is the ratio of the Amount of exports(% of total goods exports) in Upper middle income in 2012 to that in 2013?
Make the answer very short. 0.99. What is the ratio of the Amount of exports(% of total goods exports) of Oman in 2012 to that in 2013?
Your answer should be very brief. 1.23. What is the ratio of the Amount of exports(% of total goods exports) of Turkey in 2012 to that in 2013?
Provide a short and direct response. 1.19. What is the difference between the highest and the second highest Amount of exports(% of total goods exports) of Upper middle income?
Ensure brevity in your answer.  0.34. What is the difference between the highest and the second highest Amount of exports(% of total goods exports) of Oman?
Provide a short and direct response. 0. What is the difference between the highest and the second highest Amount of exports(% of total goods exports) of Turkey?
Offer a terse response. 1.03. What is the difference between the highest and the lowest Amount of exports(% of total goods exports) in Upper middle income?
Your answer should be very brief. 3.61. What is the difference between the highest and the lowest Amount of exports(% of total goods exports) in Oman?
Your answer should be very brief. 0.2. What is the difference between the highest and the lowest Amount of exports(% of total goods exports) of Turkey?
Ensure brevity in your answer.  2.26. 